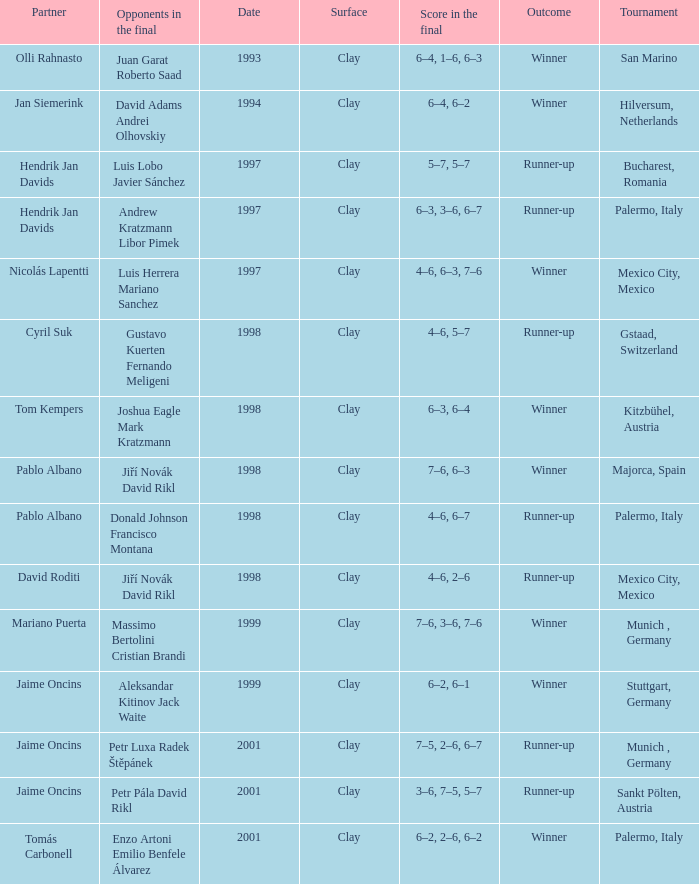Who are the Opponents in the final prior to 1998 in the Bucharest, Romania Tournament? Luis Lobo Javier Sánchez. 